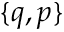<formula> <loc_0><loc_0><loc_500><loc_500>\{ q , p \}</formula> 